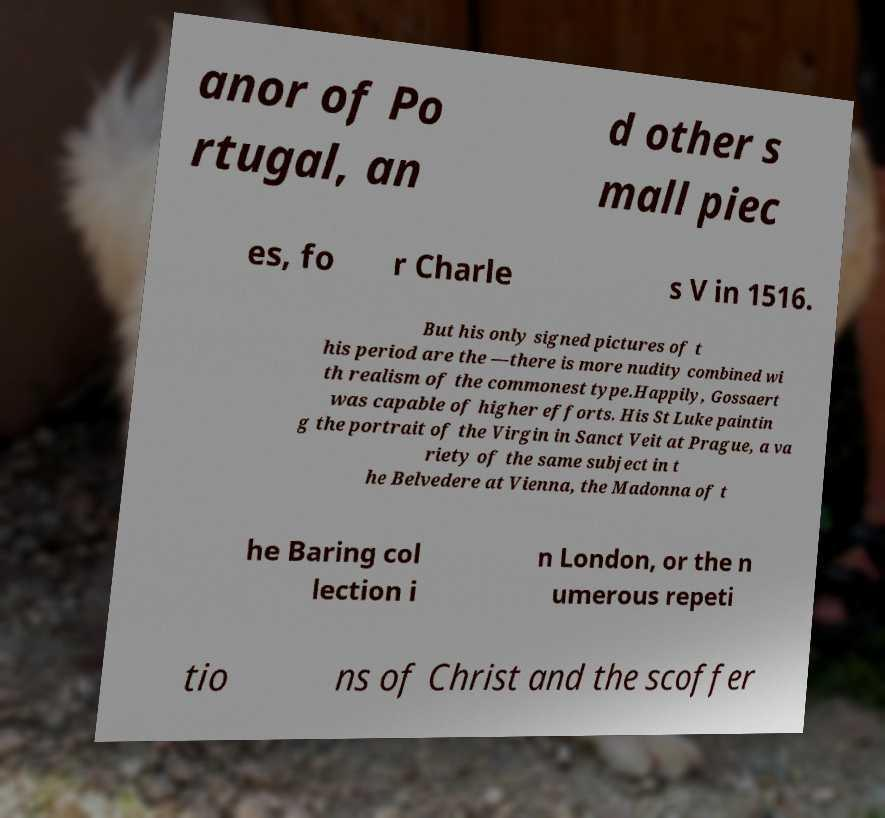Could you extract and type out the text from this image? anor of Po rtugal, an d other s mall piec es, fo r Charle s V in 1516. But his only signed pictures of t his period are the —there is more nudity combined wi th realism of the commonest type.Happily, Gossaert was capable of higher efforts. His St Luke paintin g the portrait of the Virgin in Sanct Veit at Prague, a va riety of the same subject in t he Belvedere at Vienna, the Madonna of t he Baring col lection i n London, or the n umerous repeti tio ns of Christ and the scoffer 